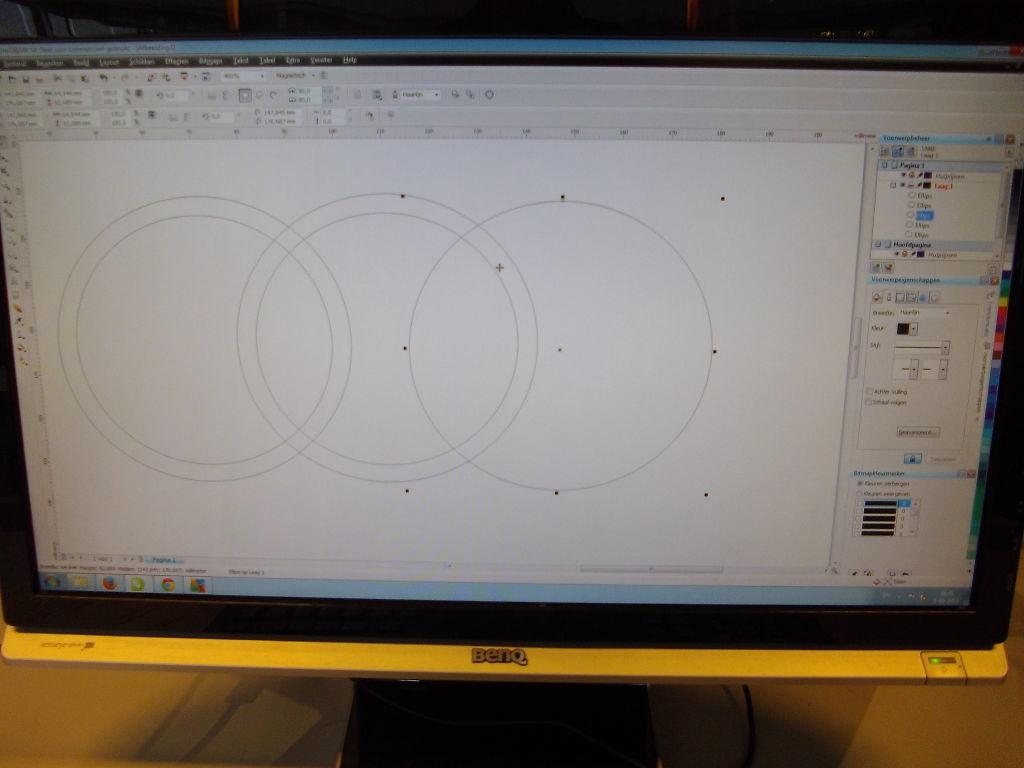<image>
Offer a succinct explanation of the picture presented. a benq computer screen with a page open with three circles on it 